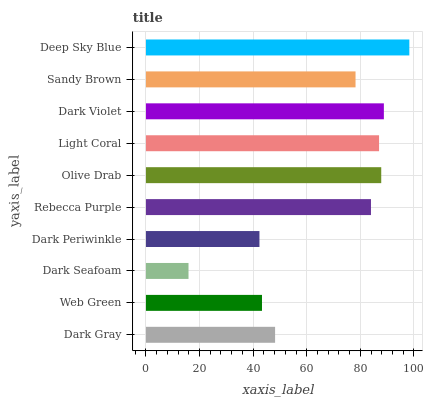Is Dark Seafoam the minimum?
Answer yes or no. Yes. Is Deep Sky Blue the maximum?
Answer yes or no. Yes. Is Web Green the minimum?
Answer yes or no. No. Is Web Green the maximum?
Answer yes or no. No. Is Dark Gray greater than Web Green?
Answer yes or no. Yes. Is Web Green less than Dark Gray?
Answer yes or no. Yes. Is Web Green greater than Dark Gray?
Answer yes or no. No. Is Dark Gray less than Web Green?
Answer yes or no. No. Is Rebecca Purple the high median?
Answer yes or no. Yes. Is Sandy Brown the low median?
Answer yes or no. Yes. Is Deep Sky Blue the high median?
Answer yes or no. No. Is Deep Sky Blue the low median?
Answer yes or no. No. 